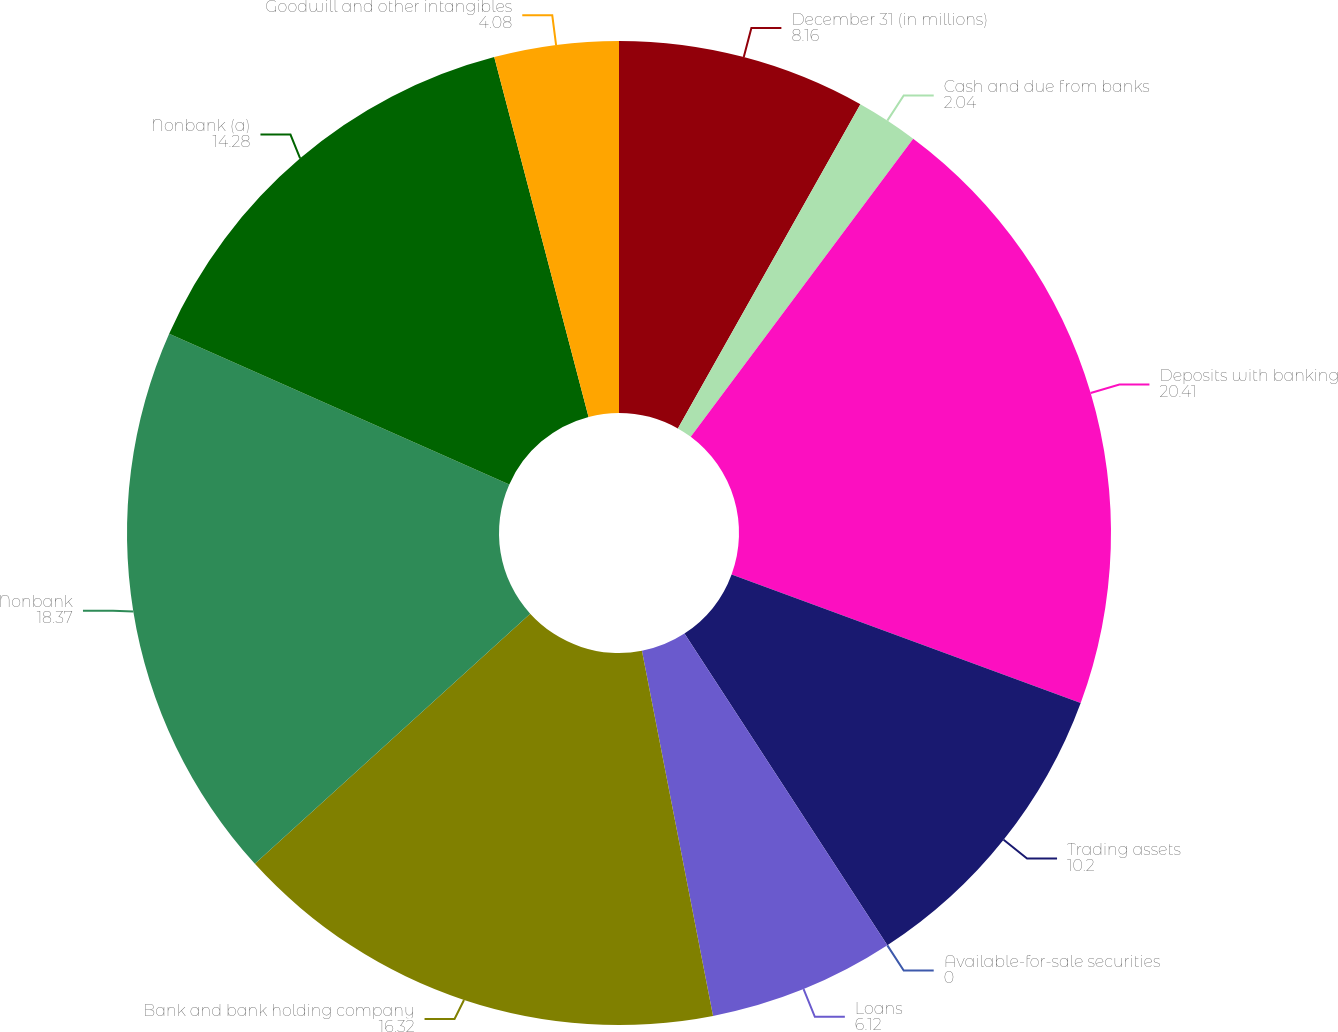Convert chart to OTSL. <chart><loc_0><loc_0><loc_500><loc_500><pie_chart><fcel>December 31 (in millions)<fcel>Cash and due from banks<fcel>Deposits with banking<fcel>Trading assets<fcel>Available-for-sale securities<fcel>Loans<fcel>Bank and bank holding company<fcel>Nonbank<fcel>Nonbank (a)<fcel>Goodwill and other intangibles<nl><fcel>8.16%<fcel>2.04%<fcel>20.41%<fcel>10.2%<fcel>0.0%<fcel>6.12%<fcel>16.32%<fcel>18.37%<fcel>14.28%<fcel>4.08%<nl></chart> 